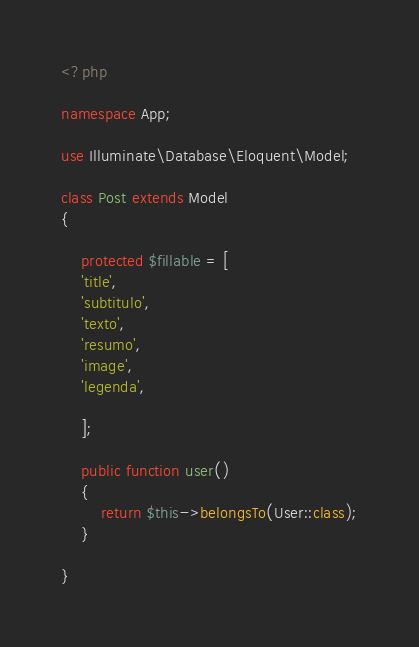<code> <loc_0><loc_0><loc_500><loc_500><_PHP_><?php

namespace App;

use Illuminate\Database\Eloquent\Model;

class Post extends Model
{
    
	protected $fillable = [
	'title',
	'subtitulo',
	'texto',
	'resumo',
	'image',
	'legenda',

	];

	public function user()
	{
		return $this->belongsTo(User::class);
	}

}
</code> 